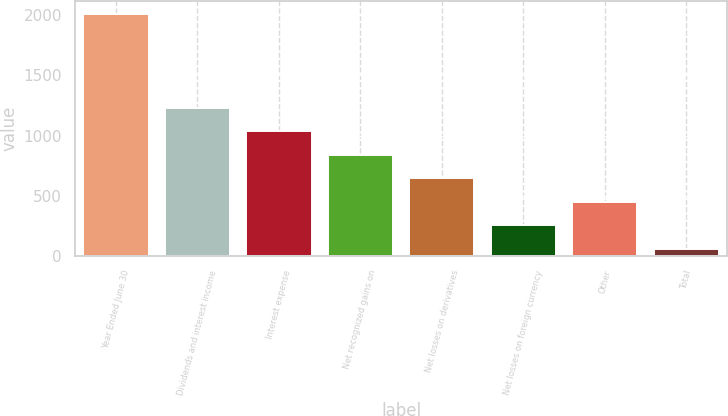Convert chart. <chart><loc_0><loc_0><loc_500><loc_500><bar_chart><fcel>Year Ended June 30<fcel>Dividends and interest income<fcel>Interest expense<fcel>Net recognized gains on<fcel>Net losses on derivatives<fcel>Net losses on foreign currency<fcel>Other<fcel>Total<nl><fcel>2014<fcel>1232.8<fcel>1037.5<fcel>842.2<fcel>646.9<fcel>256.3<fcel>451.6<fcel>61<nl></chart> 